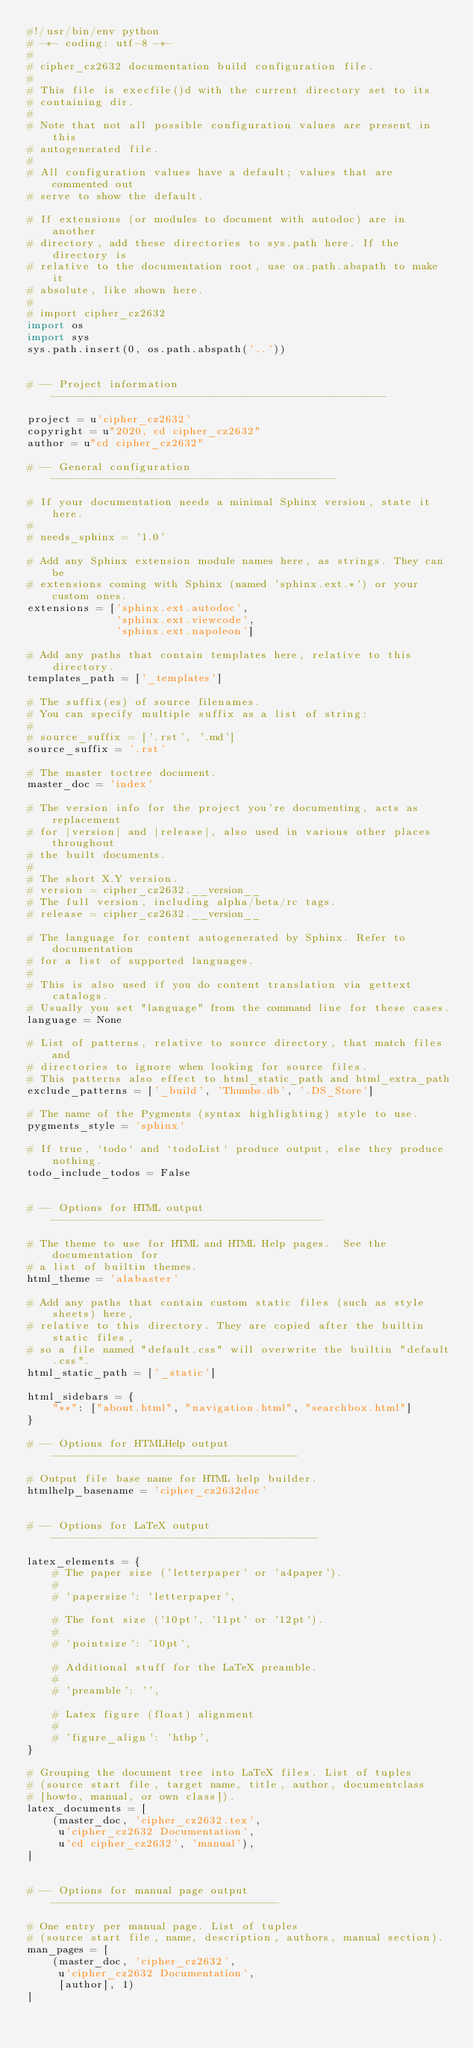Convert code to text. <code><loc_0><loc_0><loc_500><loc_500><_Python_>#!/usr/bin/env python
# -*- coding: utf-8 -*-
#
# cipher_cz2632 documentation build configuration file.
#
# This file is execfile()d with the current directory set to its
# containing dir.
#
# Note that not all possible configuration values are present in this
# autogenerated file.
#
# All configuration values have a default; values that are commented out
# serve to show the default.

# If extensions (or modules to document with autodoc) are in another
# directory, add these directories to sys.path here. If the directory is
# relative to the documentation root, use os.path.abspath to make it
# absolute, like shown here.
#
# import cipher_cz2632
import os
import sys
sys.path.insert(0, os.path.abspath('..'))


# -- Project information -----------------------------------------------------

project = u'cipher_cz2632'
copyright = u"2020, cd cipher_cz2632"
author = u"cd cipher_cz2632"

# -- General configuration ---------------------------------------------

# If your documentation needs a minimal Sphinx version, state it here.
#
# needs_sphinx = '1.0'

# Add any Sphinx extension module names here, as strings. They can be
# extensions coming with Sphinx (named 'sphinx.ext.*') or your custom ones.
extensions = ['sphinx.ext.autodoc',
              'sphinx.ext.viewcode',
              'sphinx.ext.napoleon']

# Add any paths that contain templates here, relative to this directory.
templates_path = ['_templates']

# The suffix(es) of source filenames.
# You can specify multiple suffix as a list of string:
#
# source_suffix = ['.rst', '.md']
source_suffix = '.rst'

# The master toctree document.
master_doc = 'index'

# The version info for the project you're documenting, acts as replacement
# for |version| and |release|, also used in various other places throughout
# the built documents.
#
# The short X.Y version.
# version = cipher_cz2632.__version__
# The full version, including alpha/beta/rc tags.
# release = cipher_cz2632.__version__

# The language for content autogenerated by Sphinx. Refer to documentation
# for a list of supported languages.
#
# This is also used if you do content translation via gettext catalogs.
# Usually you set "language" from the command line for these cases.
language = None

# List of patterns, relative to source directory, that match files and
# directories to ignore when looking for source files.
# This patterns also effect to html_static_path and html_extra_path
exclude_patterns = ['_build', 'Thumbs.db', '.DS_Store']

# The name of the Pygments (syntax highlighting) style to use.
pygments_style = 'sphinx'

# If true, `todo` and `todoList` produce output, else they produce nothing.
todo_include_todos = False


# -- Options for HTML output -------------------------------------------

# The theme to use for HTML and HTML Help pages.  See the documentation for
# a list of builtin themes.
html_theme = 'alabaster'

# Add any paths that contain custom static files (such as style sheets) here,
# relative to this directory. They are copied after the builtin static files,
# so a file named "default.css" will overwrite the builtin "default.css".
html_static_path = ['_static']

html_sidebars = {
    "**": ["about.html", "navigation.html", "searchbox.html"]
}

# -- Options for HTMLHelp output ---------------------------------------

# Output file base name for HTML help builder.
htmlhelp_basename = 'cipher_cz2632doc'


# -- Options for LaTeX output ------------------------------------------

latex_elements = {
    # The paper size ('letterpaper' or 'a4paper').
    #
    # 'papersize': 'letterpaper',

    # The font size ('10pt', '11pt' or '12pt').
    #
    # 'pointsize': '10pt',

    # Additional stuff for the LaTeX preamble.
    #
    # 'preamble': '',

    # Latex figure (float) alignment
    #
    # 'figure_align': 'htbp',
}

# Grouping the document tree into LaTeX files. List of tuples
# (source start file, target name, title, author, documentclass
# [howto, manual, or own class]).
latex_documents = [
    (master_doc, 'cipher_cz2632.tex',
     u'cipher_cz2632 Documentation',
     u'cd cipher_cz2632', 'manual'),
]


# -- Options for manual page output ------------------------------------

# One entry per manual page. List of tuples
# (source start file, name, description, authors, manual section).
man_pages = [
    (master_doc, 'cipher_cz2632',
     u'cipher_cz2632 Documentation',
     [author], 1)
]

</code> 